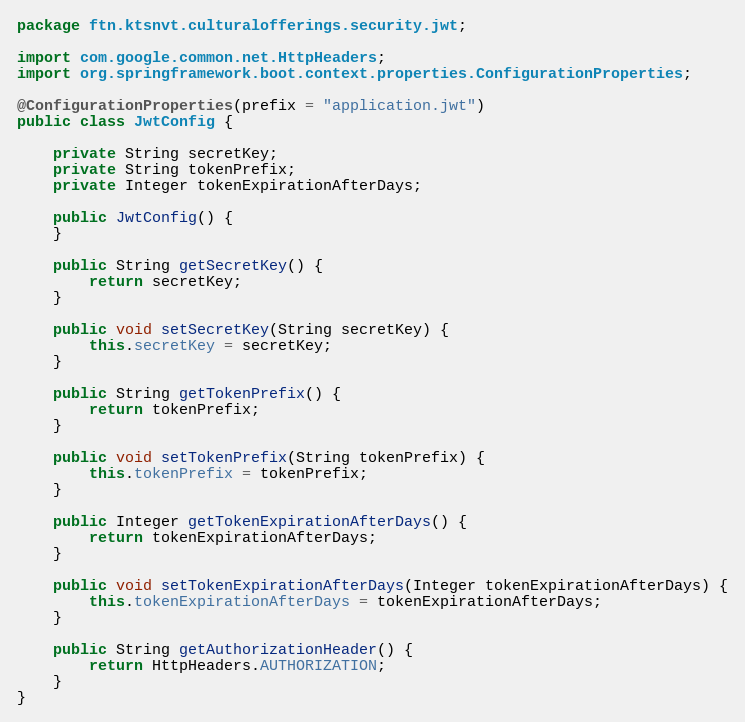<code> <loc_0><loc_0><loc_500><loc_500><_Java_>package ftn.ktsnvt.culturalofferings.security.jwt;

import com.google.common.net.HttpHeaders;
import org.springframework.boot.context.properties.ConfigurationProperties;

@ConfigurationProperties(prefix = "application.jwt")
public class JwtConfig {

    private String secretKey;
    private String tokenPrefix;
    private Integer tokenExpirationAfterDays;

    public JwtConfig() {
    }

    public String getSecretKey() {
        return secretKey;
    }

    public void setSecretKey(String secretKey) {
        this.secretKey = secretKey;
    }

    public String getTokenPrefix() {
        return tokenPrefix;
    }

    public void setTokenPrefix(String tokenPrefix) {
        this.tokenPrefix = tokenPrefix;
    }

    public Integer getTokenExpirationAfterDays() {
        return tokenExpirationAfterDays;
    }

    public void setTokenExpirationAfterDays(Integer tokenExpirationAfterDays) {
        this.tokenExpirationAfterDays = tokenExpirationAfterDays;
    }

    public String getAuthorizationHeader() {
        return HttpHeaders.AUTHORIZATION;
    }
}</code> 